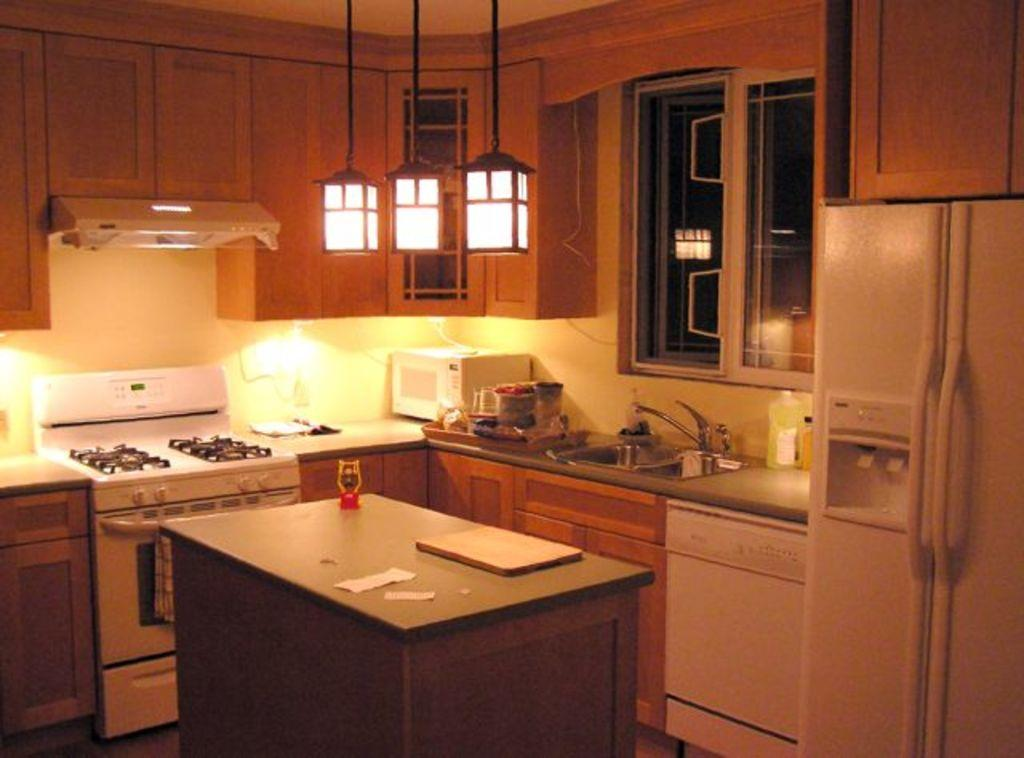What type of items can be seen in the image related to cooking? There is kitchenware, an oven, and a stove in the image. What is the purpose of the chimney in the image? The chimney is likely for ventilation purposes, as it is often used to remove smoke and fumes from cooking. What can be seen near the window in the image? There is a table near the window in the image. Where is the cushion placed in the image? There is no cushion present in the image. What is the yoke used for in the image? There is no yoke present in the image. 